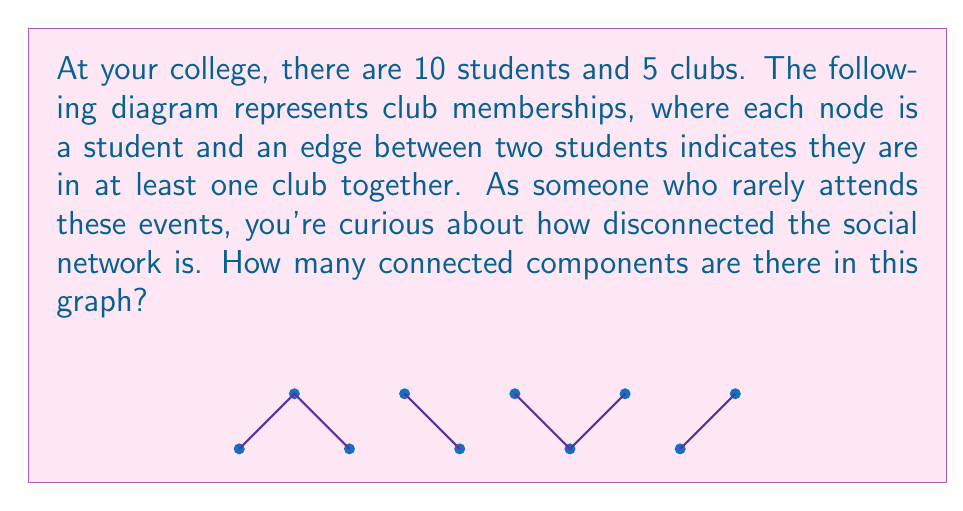Can you solve this math problem? To find the number of connected components in this graph, we need to identify groups of nodes that are connected to each other but disconnected from other groups. Let's approach this step-by-step:

1) First, let's identify each connected group:
   - Group 1: Students 1, 2, and 3 (nodes at positions 0, 1, and 2)
   - Group 2: Students 4 and 5 (nodes at positions 3 and 4)
   - Group 3: Students 6, 7, and 8 (nodes at positions 5, 6, and 7)
   - Group 4: Students 9 and 10 (nodes at positions 8 and 9)

2) Now, let's count these groups:
   We have identified 4 separate groups.

3) In graph theory, each of these separate groups is called a connected component.

4) The number of connected components is equal to the number of these separate groups.

Therefore, the graph has 4 connected components.

This result indicates that the social network among these 10 students is quite disconnected, which aligns with the persona of someone who rarely attends these types of events and might not be aware of the full extent of social connections.
Answer: 4 